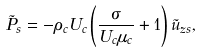<formula> <loc_0><loc_0><loc_500><loc_500>\tilde { P } _ { s } = - \rho _ { c } U _ { c } \left ( \frac { \sigma } { U _ { c } \mu _ { c } } + 1 \right ) \tilde { u } _ { z s } ,</formula> 